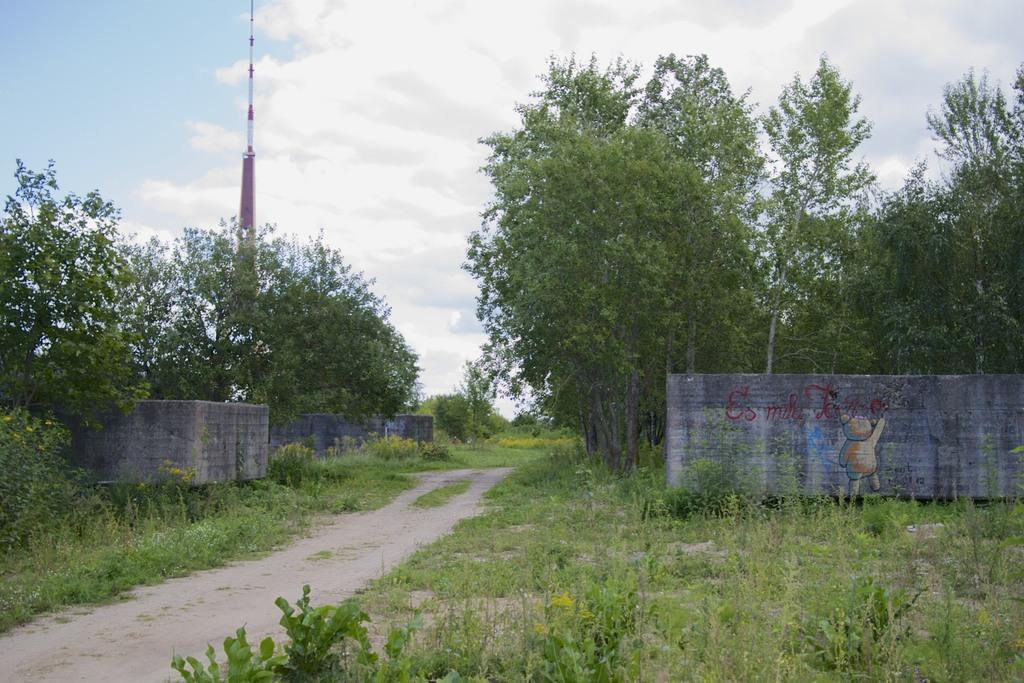Please provide a concise description of this image. In this image we can see trees, plants, pole and in the background we can see the sky. 